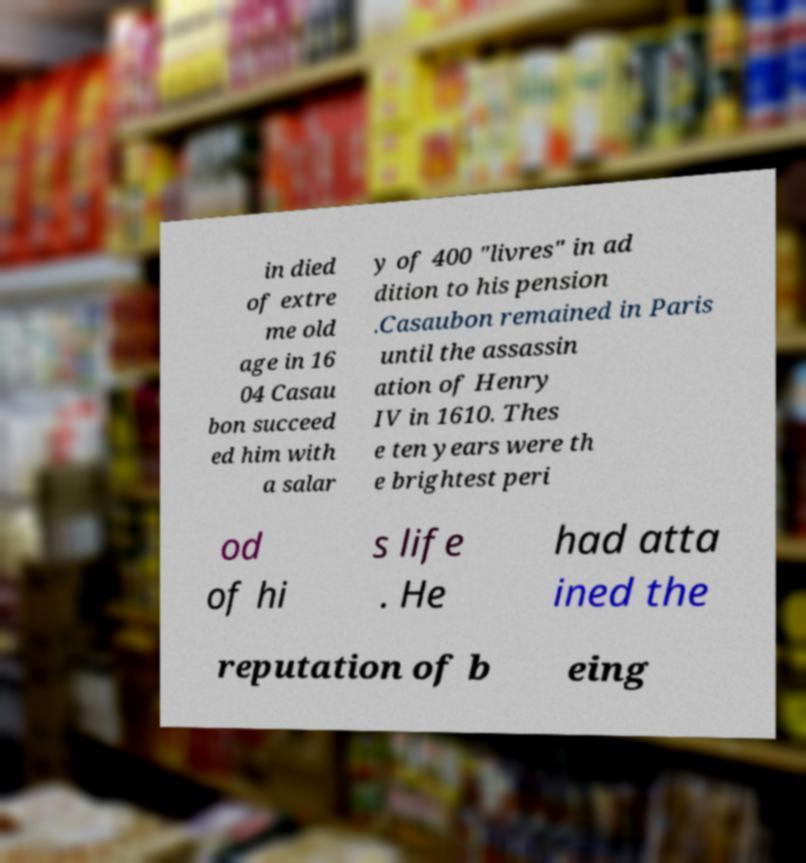Please identify and transcribe the text found in this image. in died of extre me old age in 16 04 Casau bon succeed ed him with a salar y of 400 "livres" in ad dition to his pension .Casaubon remained in Paris until the assassin ation of Henry IV in 1610. Thes e ten years were th e brightest peri od of hi s life . He had atta ined the reputation of b eing 